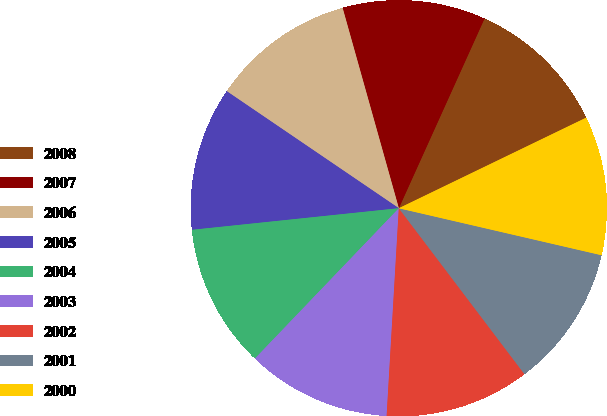<chart> <loc_0><loc_0><loc_500><loc_500><pie_chart><fcel>2008<fcel>2007<fcel>2006<fcel>2005<fcel>2004<fcel>2003<fcel>2002<fcel>2001<fcel>2000<nl><fcel>11.08%<fcel>11.11%<fcel>11.14%<fcel>11.16%<fcel>11.19%<fcel>11.22%<fcel>11.25%<fcel>11.06%<fcel>10.79%<nl></chart> 